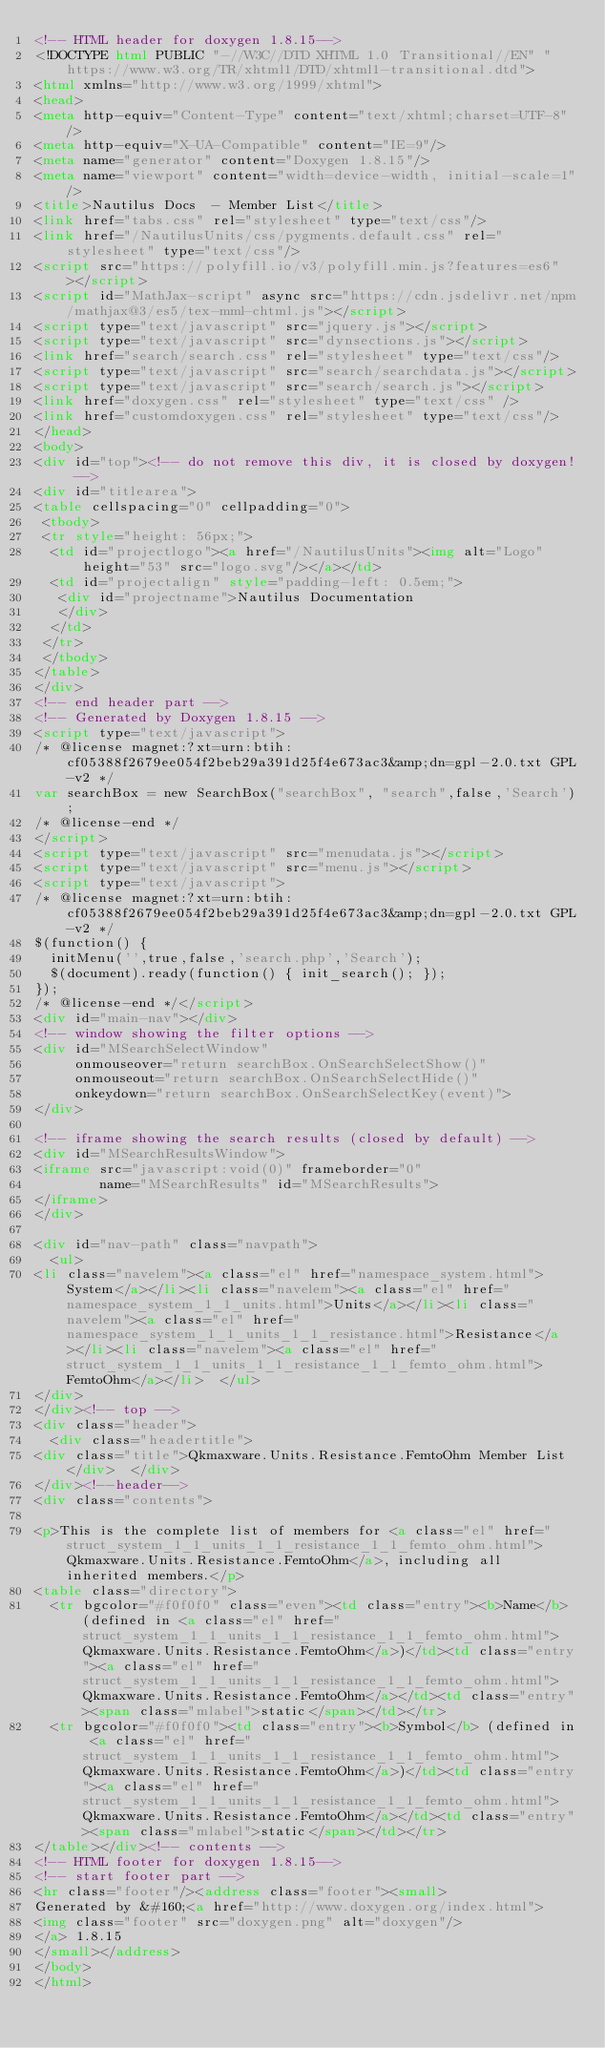<code> <loc_0><loc_0><loc_500><loc_500><_HTML_><!-- HTML header for doxygen 1.8.15-->
<!DOCTYPE html PUBLIC "-//W3C//DTD XHTML 1.0 Transitional//EN" "https://www.w3.org/TR/xhtml1/DTD/xhtml1-transitional.dtd">
<html xmlns="http://www.w3.org/1999/xhtml">
<head>
<meta http-equiv="Content-Type" content="text/xhtml;charset=UTF-8"/>
<meta http-equiv="X-UA-Compatible" content="IE=9"/>
<meta name="generator" content="Doxygen 1.8.15"/>
<meta name="viewport" content="width=device-width, initial-scale=1"/>
<title>Nautilus Docs  - Member List</title>
<link href="tabs.css" rel="stylesheet" type="text/css"/>
<link href="/NautilusUnits/css/pygments.default.css" rel="stylesheet" type="text/css"/>
<script src="https://polyfill.io/v3/polyfill.min.js?features=es6"></script>
<script id="MathJax-script" async src="https://cdn.jsdelivr.net/npm/mathjax@3/es5/tex-mml-chtml.js"></script>
<script type="text/javascript" src="jquery.js"></script>
<script type="text/javascript" src="dynsections.js"></script>
<link href="search/search.css" rel="stylesheet" type="text/css"/>
<script type="text/javascript" src="search/searchdata.js"></script>
<script type="text/javascript" src="search/search.js"></script>
<link href="doxygen.css" rel="stylesheet" type="text/css" />
<link href="customdoxygen.css" rel="stylesheet" type="text/css"/>
</head>
<body>
<div id="top"><!-- do not remove this div, it is closed by doxygen! -->
<div id="titlearea">
<table cellspacing="0" cellpadding="0">
 <tbody>
 <tr style="height: 56px;">
  <td id="projectlogo"><a href="/NautilusUnits"><img alt="Logo" height="53" src="logo.svg"/></a></td>
  <td id="projectalign" style="padding-left: 0.5em;">
   <div id="projectname">Nautilus Documentation
   </div>
  </td>
 </tr>
 </tbody>
</table>
</div>
<!-- end header part -->
<!-- Generated by Doxygen 1.8.15 -->
<script type="text/javascript">
/* @license magnet:?xt=urn:btih:cf05388f2679ee054f2beb29a391d25f4e673ac3&amp;dn=gpl-2.0.txt GPL-v2 */
var searchBox = new SearchBox("searchBox", "search",false,'Search');
/* @license-end */
</script>
<script type="text/javascript" src="menudata.js"></script>
<script type="text/javascript" src="menu.js"></script>
<script type="text/javascript">
/* @license magnet:?xt=urn:btih:cf05388f2679ee054f2beb29a391d25f4e673ac3&amp;dn=gpl-2.0.txt GPL-v2 */
$(function() {
  initMenu('',true,false,'search.php','Search');
  $(document).ready(function() { init_search(); });
});
/* @license-end */</script>
<div id="main-nav"></div>
<!-- window showing the filter options -->
<div id="MSearchSelectWindow"
     onmouseover="return searchBox.OnSearchSelectShow()"
     onmouseout="return searchBox.OnSearchSelectHide()"
     onkeydown="return searchBox.OnSearchSelectKey(event)">
</div>

<!-- iframe showing the search results (closed by default) -->
<div id="MSearchResultsWindow">
<iframe src="javascript:void(0)" frameborder="0" 
        name="MSearchResults" id="MSearchResults">
</iframe>
</div>

<div id="nav-path" class="navpath">
  <ul>
<li class="navelem"><a class="el" href="namespace_system.html">System</a></li><li class="navelem"><a class="el" href="namespace_system_1_1_units.html">Units</a></li><li class="navelem"><a class="el" href="namespace_system_1_1_units_1_1_resistance.html">Resistance</a></li><li class="navelem"><a class="el" href="struct_system_1_1_units_1_1_resistance_1_1_femto_ohm.html">FemtoOhm</a></li>  </ul>
</div>
</div><!-- top -->
<div class="header">
  <div class="headertitle">
<div class="title">Qkmaxware.Units.Resistance.FemtoOhm Member List</div>  </div>
</div><!--header-->
<div class="contents">

<p>This is the complete list of members for <a class="el" href="struct_system_1_1_units_1_1_resistance_1_1_femto_ohm.html">Qkmaxware.Units.Resistance.FemtoOhm</a>, including all inherited members.</p>
<table class="directory">
  <tr bgcolor="#f0f0f0" class="even"><td class="entry"><b>Name</b> (defined in <a class="el" href="struct_system_1_1_units_1_1_resistance_1_1_femto_ohm.html">Qkmaxware.Units.Resistance.FemtoOhm</a>)</td><td class="entry"><a class="el" href="struct_system_1_1_units_1_1_resistance_1_1_femto_ohm.html">Qkmaxware.Units.Resistance.FemtoOhm</a></td><td class="entry"><span class="mlabel">static</span></td></tr>
  <tr bgcolor="#f0f0f0"><td class="entry"><b>Symbol</b> (defined in <a class="el" href="struct_system_1_1_units_1_1_resistance_1_1_femto_ohm.html">Qkmaxware.Units.Resistance.FemtoOhm</a>)</td><td class="entry"><a class="el" href="struct_system_1_1_units_1_1_resistance_1_1_femto_ohm.html">Qkmaxware.Units.Resistance.FemtoOhm</a></td><td class="entry"><span class="mlabel">static</span></td></tr>
</table></div><!-- contents -->
<!-- HTML footer for doxygen 1.8.15-->
<!-- start footer part -->
<hr class="footer"/><address class="footer"><small>
Generated by &#160;<a href="http://www.doxygen.org/index.html">
<img class="footer" src="doxygen.png" alt="doxygen"/>
</a> 1.8.15
</small></address>
</body>
</html>
</code> 